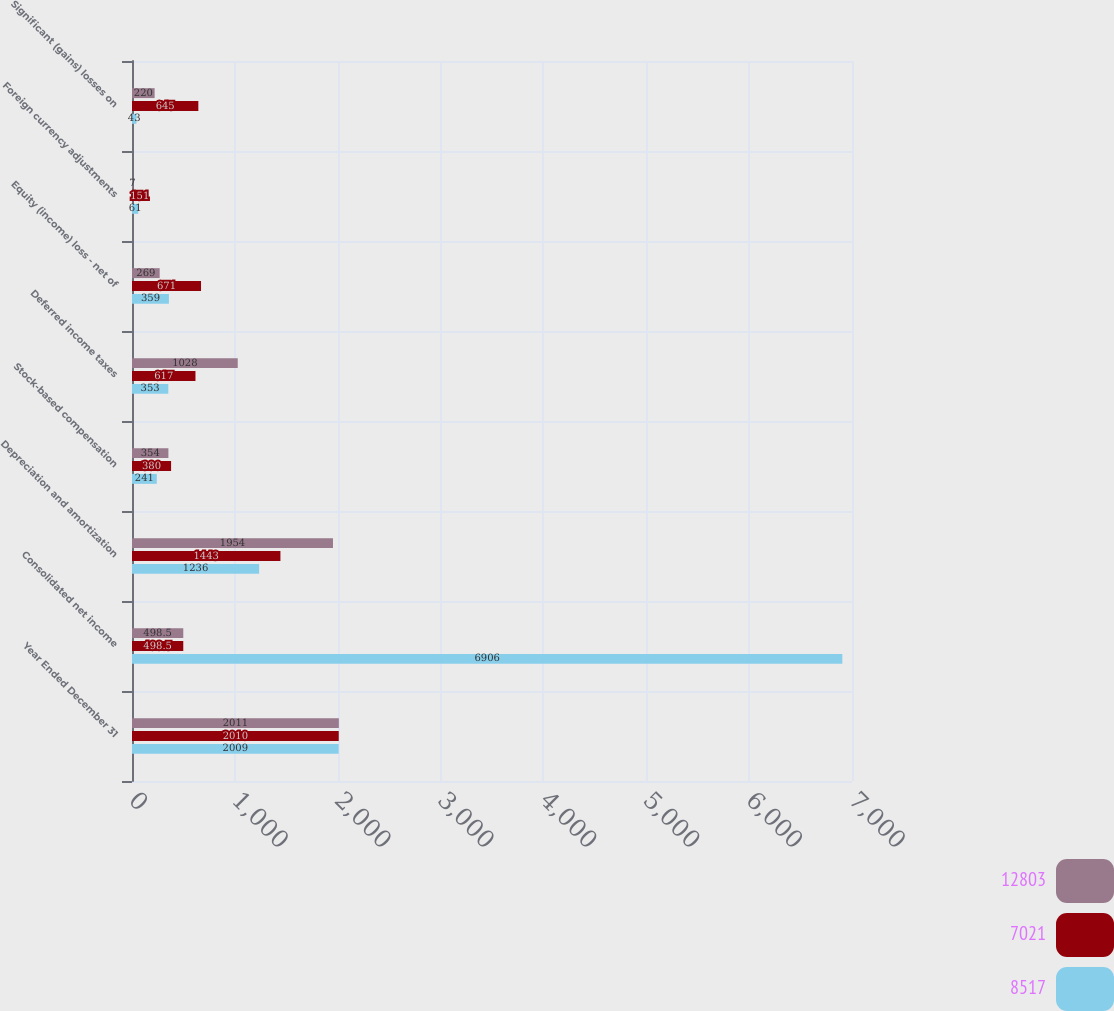Convert chart to OTSL. <chart><loc_0><loc_0><loc_500><loc_500><stacked_bar_chart><ecel><fcel>Year Ended December 31<fcel>Consolidated net income<fcel>Depreciation and amortization<fcel>Stock-based compensation<fcel>Deferred income taxes<fcel>Equity (income) loss - net of<fcel>Foreign currency adjustments<fcel>Significant (gains) losses on<nl><fcel>12803<fcel>2011<fcel>498.5<fcel>1954<fcel>354<fcel>1028<fcel>269<fcel>7<fcel>220<nl><fcel>7021<fcel>2010<fcel>498.5<fcel>1443<fcel>380<fcel>617<fcel>671<fcel>151<fcel>645<nl><fcel>8517<fcel>2009<fcel>6906<fcel>1236<fcel>241<fcel>353<fcel>359<fcel>61<fcel>43<nl></chart> 